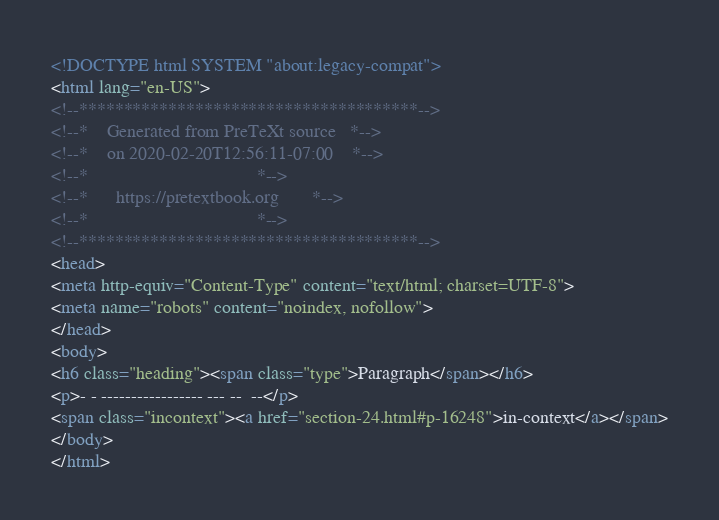Convert code to text. <code><loc_0><loc_0><loc_500><loc_500><_HTML_><!DOCTYPE html SYSTEM "about:legacy-compat">
<html lang="en-US">
<!--**************************************-->
<!--*    Generated from PreTeXt source   *-->
<!--*    on 2020-02-20T12:56:11-07:00    *-->
<!--*                                    *-->
<!--*      https://pretextbook.org       *-->
<!--*                                    *-->
<!--**************************************-->
<head>
<meta http-equiv="Content-Type" content="text/html; charset=UTF-8">
<meta name="robots" content="noindex, nofollow">
</head>
<body>
<h6 class="heading"><span class="type">Paragraph</span></h6>
<p>- - ----------------- --- --  --</p>
<span class="incontext"><a href="section-24.html#p-16248">in-context</a></span>
</body>
</html>
</code> 